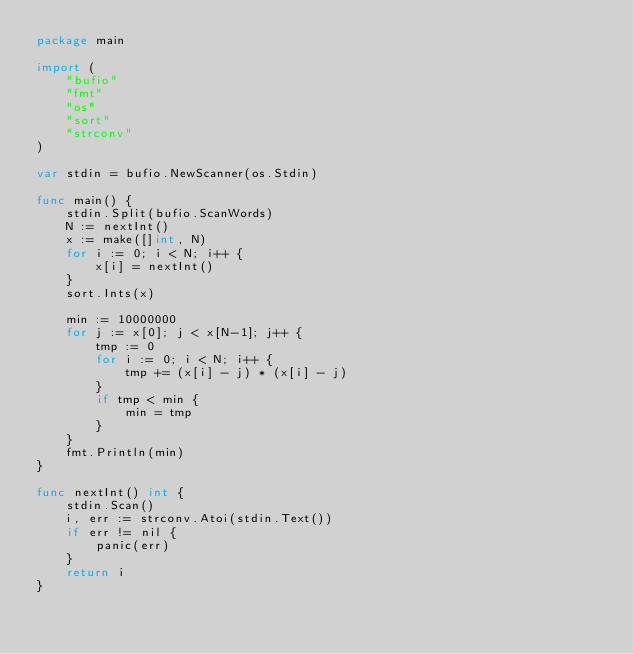<code> <loc_0><loc_0><loc_500><loc_500><_Go_>package main

import (
	"bufio"
	"fmt"
	"os"
	"sort"
	"strconv"
)

var stdin = bufio.NewScanner(os.Stdin)

func main() {
	stdin.Split(bufio.ScanWords)
	N := nextInt()
	x := make([]int, N)
	for i := 0; i < N; i++ {
		x[i] = nextInt()
	}
	sort.Ints(x)

	min := 10000000
	for j := x[0]; j < x[N-1]; j++ {
		tmp := 0
		for i := 0; i < N; i++ {
			tmp += (x[i] - j) * (x[i] - j)
		}
		if tmp < min {
			min = tmp
		}
	}
	fmt.Println(min)
}

func nextInt() int {
	stdin.Scan()
	i, err := strconv.Atoi(stdin.Text())
	if err != nil {
		panic(err)
	}
	return i
}
</code> 